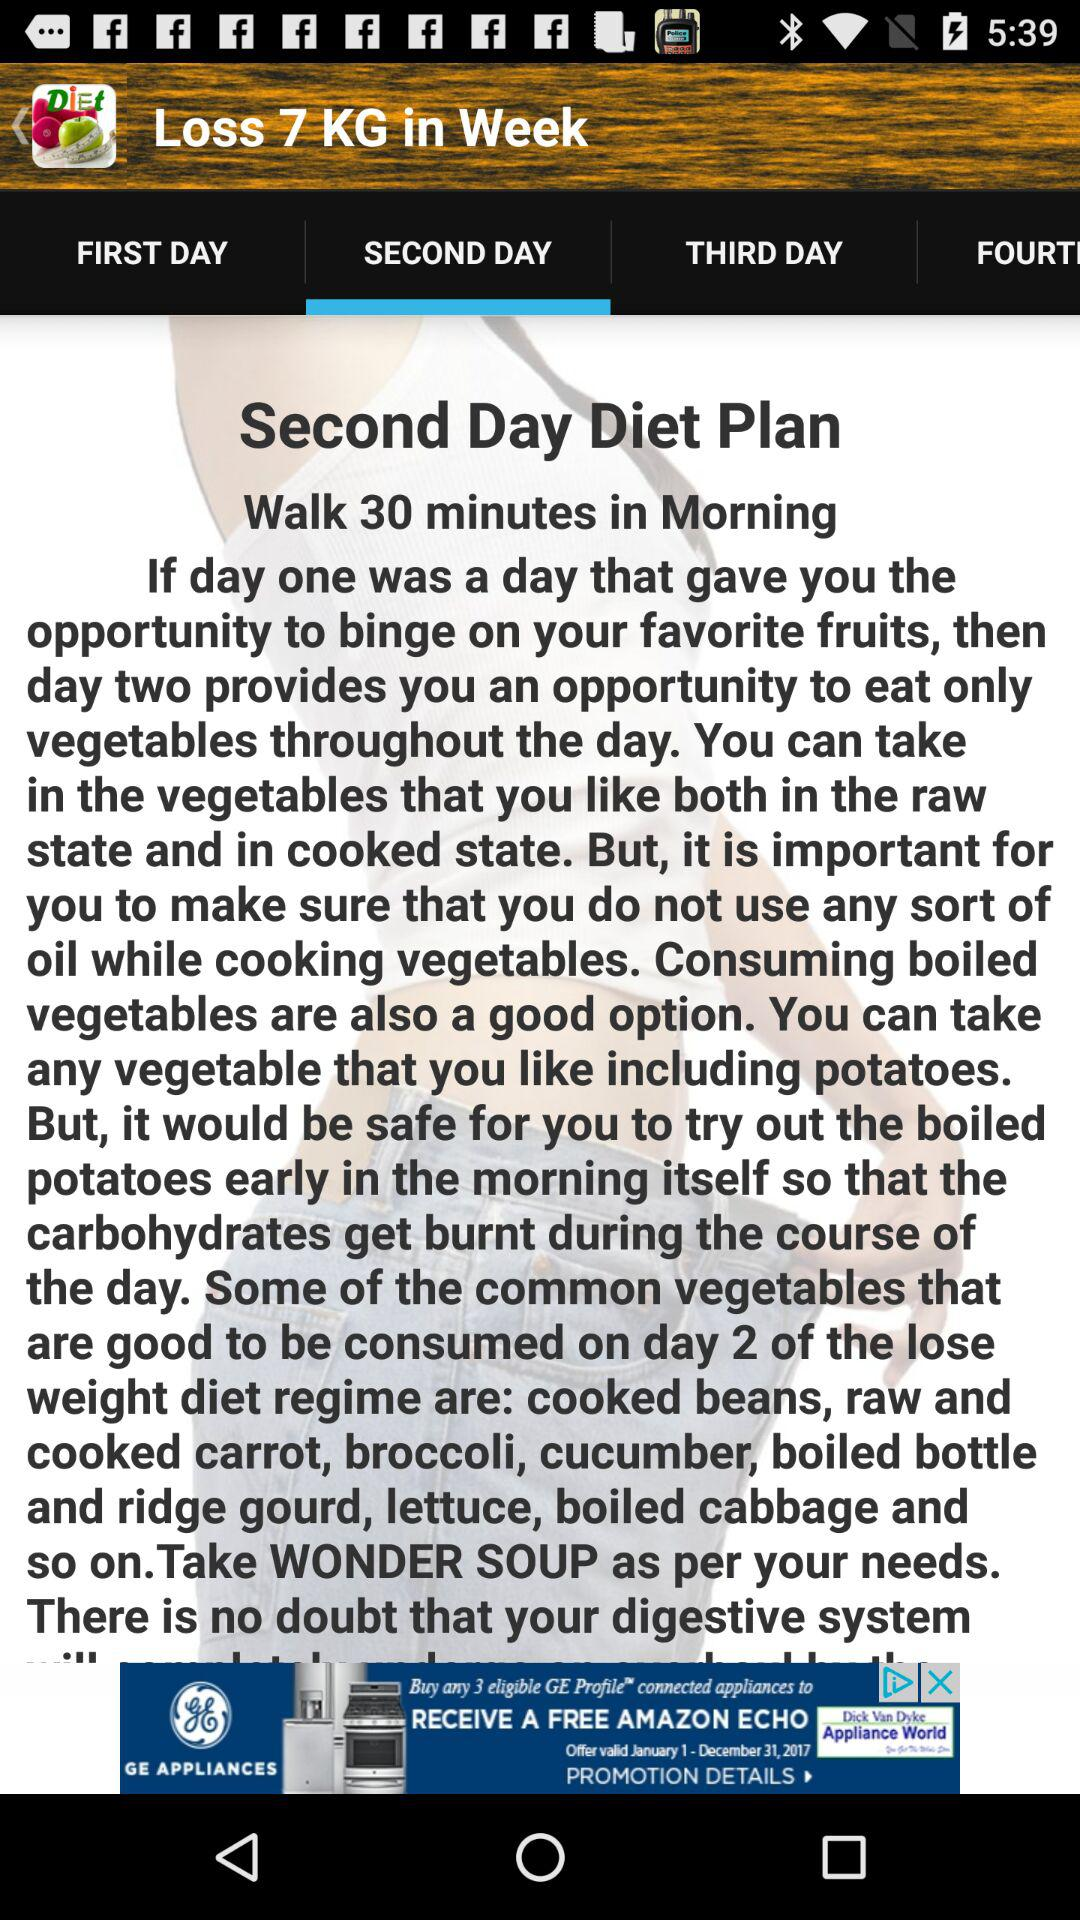Which option has been selected? The option that has been selected is "SECOND DAY". 